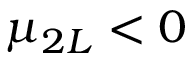Convert formula to latex. <formula><loc_0><loc_0><loc_500><loc_500>\mu _ { 2 L } < 0</formula> 